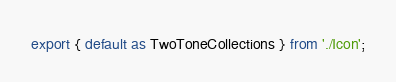Convert code to text. <code><loc_0><loc_0><loc_500><loc_500><_TypeScript_>export { default as TwoToneCollections } from './Icon';
</code> 